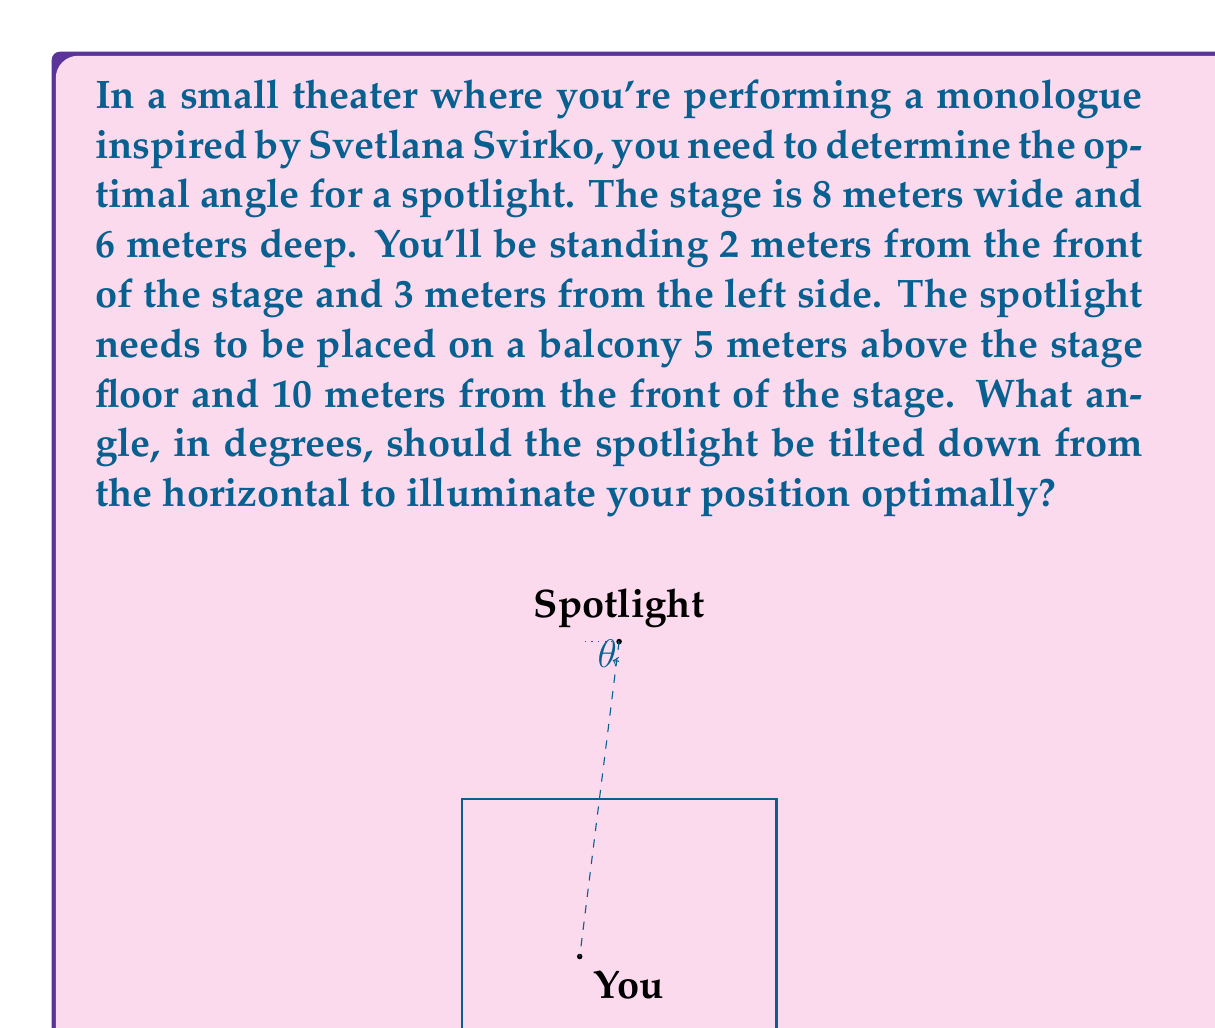Show me your answer to this math problem. Let's approach this step-by-step:

1) First, we need to find the horizontal distance from the spotlight to your position:
   - The spotlight is 10m from the front of the stage, you're 2m from the front.
   - Horizontal distance = $10 - 2 = 8$ meters

2) Now, let's find the lateral distance:
   - The stage is 8m wide, the spotlight is centered (at 4m), you're 3m from the left.
   - Lateral distance = $4 - 3 = 1$ meter

3) We can now calculate the total horizontal distance using the Pythagorean theorem:
   $d = \sqrt{8^2 + 1^2} = \sqrt{65}$ meters

4) The vertical distance is given as 5 meters.

5) We now have a right triangle where:
   - The adjacent side is $\sqrt{65}$ meters
   - The opposite side is 5 meters

6) We can use the arctangent function to find the angle:

   $\theta = \arctan(\frac{\text{opposite}}{\text{adjacent}}) = \arctan(\frac{5}{\sqrt{65}})$

7) Converting to degrees:

   $\theta = \arctan(\frac{5}{\sqrt{65}}) \cdot \frac{180}{\pi}$ degrees

8) Calculating this gives us approximately 31.79 degrees.
Answer: $31.79^\circ$ 